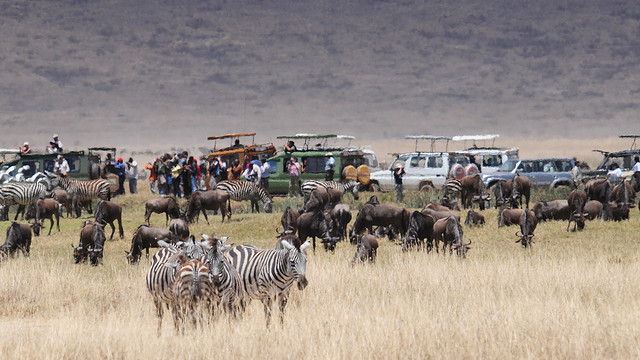How many trucks are there? Referring to trucks specifically is challenging without a clear view of the entire scene. However, it is noticeable that there are several vehicles in the background, likely engaged in safari tourism. The exact number of trucks visible in this image cannot be determined due to the angle and the presence of wildlife partially obscuring the view. 